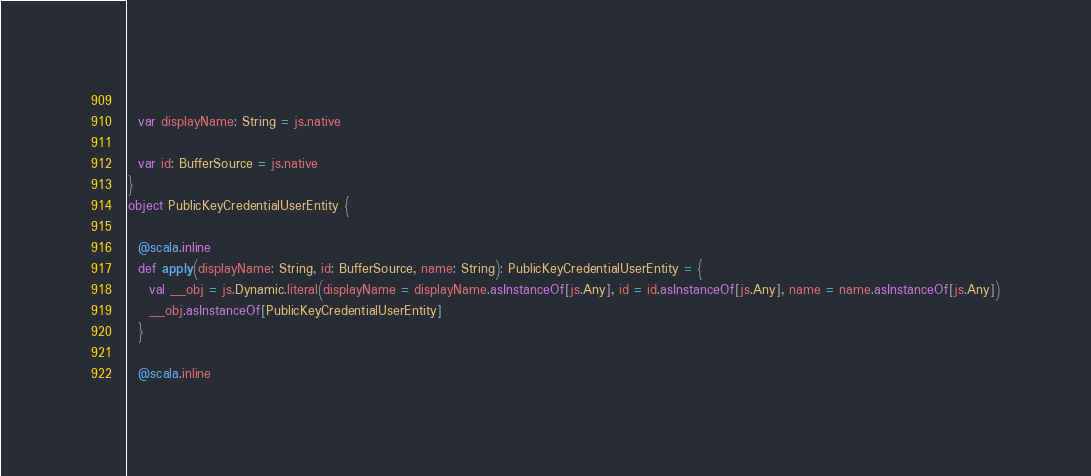<code> <loc_0><loc_0><loc_500><loc_500><_Scala_>  
  var displayName: String = js.native
  
  var id: BufferSource = js.native
}
object PublicKeyCredentialUserEntity {
  
  @scala.inline
  def apply(displayName: String, id: BufferSource, name: String): PublicKeyCredentialUserEntity = {
    val __obj = js.Dynamic.literal(displayName = displayName.asInstanceOf[js.Any], id = id.asInstanceOf[js.Any], name = name.asInstanceOf[js.Any])
    __obj.asInstanceOf[PublicKeyCredentialUserEntity]
  }
  
  @scala.inline</code> 